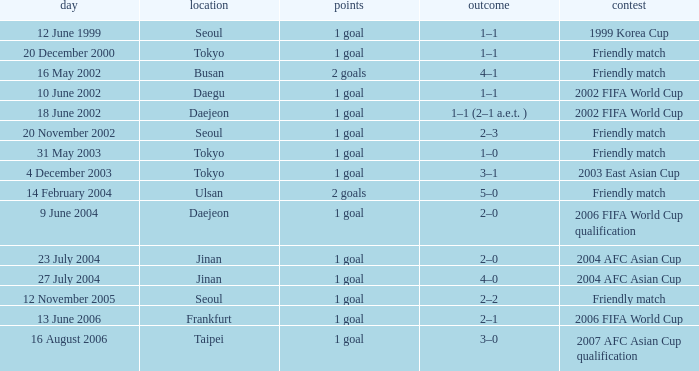What is the venue of the game on 20 November 2002? Seoul. 